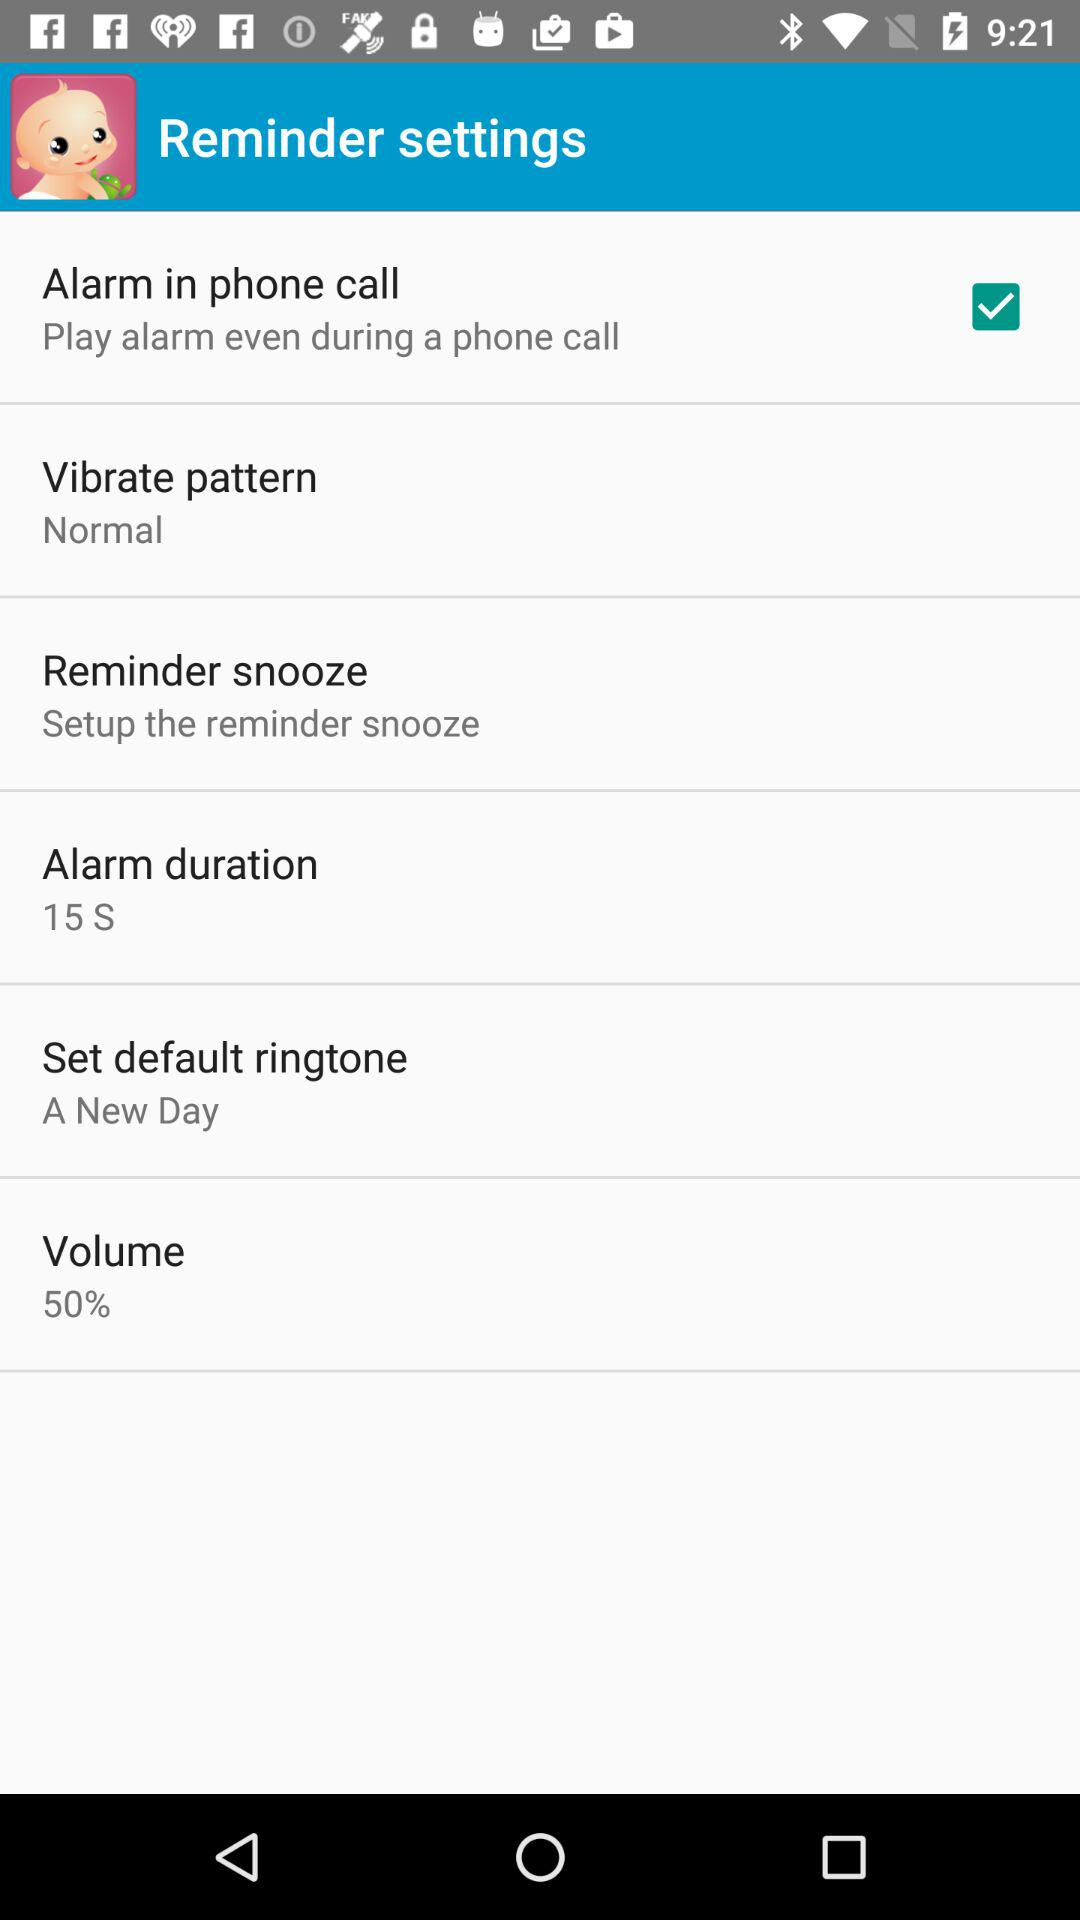What is the current status of "Alarm in phone call"? The current status of "Alarm in phone call" is "on". 